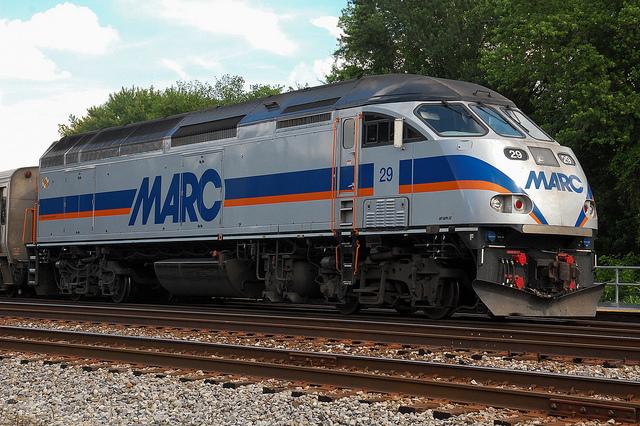Do you see a name on the train?
Quick response, please. Yes. How many times is the train number visible?
Be succinct. 3. What color is the train?
Write a very short answer. Silver. 